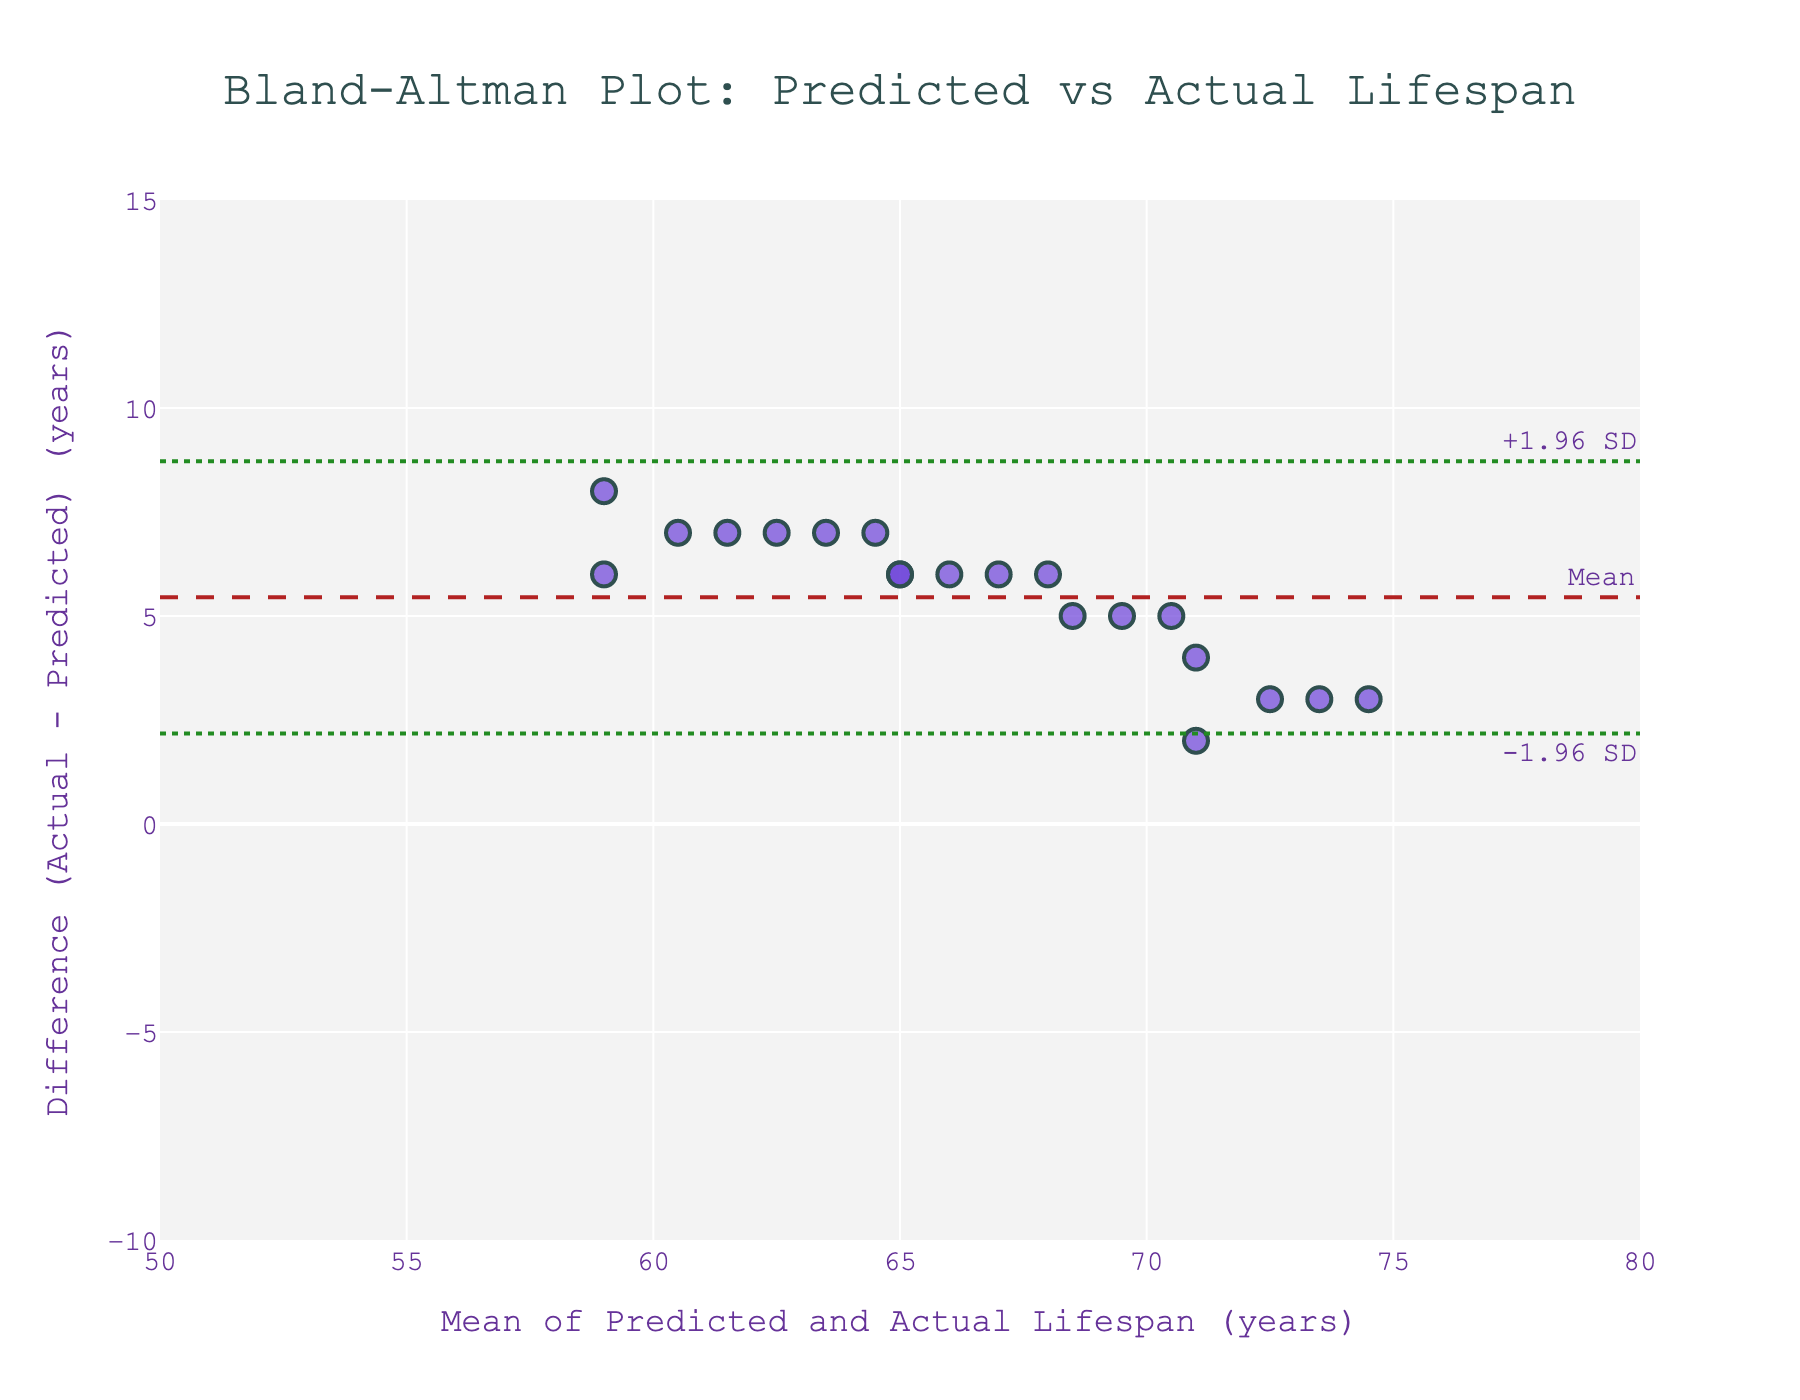What is the title of the plot? The title is typically located at the top of the plot. Here, it reads "Bland-Altman Plot: Predicted vs Actual Lifespan".
Answer: Bland-Altman Plot: Predicted vs Actual Lifespan What is the x-axis label of the plot? The x-axis label is found below the horizontal axis. It reads "Mean of Predicted and Actual Lifespan (years)".
Answer: Mean of Predicted and Actual Lifespan (years) What is the y-axis label of the plot? The y-axis label is located next to the vertical axis. It reads "Difference (Actual - Predicted) (years)".
Answer: Difference (Actual - Predicted) (years) How many data points are plotted on the figure? To determine the number of data points, count the number of markers on the scatter plot. Here, there are 20 markers.
Answer: 20 What is the mean difference between actual and predicted lifespans? The mean difference line is annotated on the plot as "Mean" and is shown using a dashed line. The mean difference can be found where this line intersects the y-axis. It looks to be around slightly above 5 years.
Answer: Slightly above 5 years What are the upper and lower limits of agreement? The limits of agreement lines are annotated as "+1.96 SD" and "-1.96 SD". These are plotted as dotted lines. The upper limit is approximately 13 years and the lower limit is approximately -3 years.
Answer: +1.96 SD ~ 13, -1.96 SD ~ -3 What does a positive difference (y-value) indicate in this plot? A positive difference indicates that the actual lifespan was greater than the predicted lifespan.
Answer: Actual > Predicted What does a negative difference (y-value) indicate in this plot? A negative difference indicates that the actual lifespan was less than the predicted lifespan.
Answer: Actual < Predicted Does the plot indicate a systematic bias in predictions relative to actual lifespans? To determine systematic bias, observe if most data points fall consistently above or below the mean difference line. Most points appear above, indicating predictions were generally lower than actual lifespans.
Answer: Yes, predictions were generally lower 